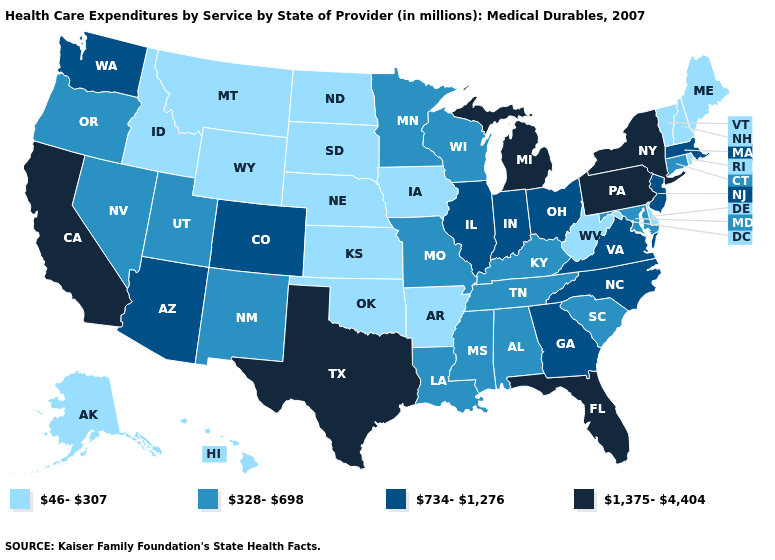Is the legend a continuous bar?
Concise answer only. No. Does the first symbol in the legend represent the smallest category?
Keep it brief. Yes. Name the states that have a value in the range 328-698?
Keep it brief. Alabama, Connecticut, Kentucky, Louisiana, Maryland, Minnesota, Mississippi, Missouri, Nevada, New Mexico, Oregon, South Carolina, Tennessee, Utah, Wisconsin. Does Massachusetts have the lowest value in the USA?
Short answer required. No. Name the states that have a value in the range 328-698?
Give a very brief answer. Alabama, Connecticut, Kentucky, Louisiana, Maryland, Minnesota, Mississippi, Missouri, Nevada, New Mexico, Oregon, South Carolina, Tennessee, Utah, Wisconsin. Does Montana have the same value as Vermont?
Quick response, please. Yes. What is the value of Tennessee?
Answer briefly. 328-698. What is the highest value in the USA?
Answer briefly. 1,375-4,404. Name the states that have a value in the range 46-307?
Quick response, please. Alaska, Arkansas, Delaware, Hawaii, Idaho, Iowa, Kansas, Maine, Montana, Nebraska, New Hampshire, North Dakota, Oklahoma, Rhode Island, South Dakota, Vermont, West Virginia, Wyoming. Among the states that border Utah , does Wyoming have the lowest value?
Concise answer only. Yes. What is the highest value in states that border Virginia?
Give a very brief answer. 734-1,276. Does New York have the highest value in the Northeast?
Give a very brief answer. Yes. What is the value of Idaho?
Be succinct. 46-307. Does Connecticut have the lowest value in the Northeast?
Answer briefly. No. Among the states that border Louisiana , does Texas have the highest value?
Quick response, please. Yes. 